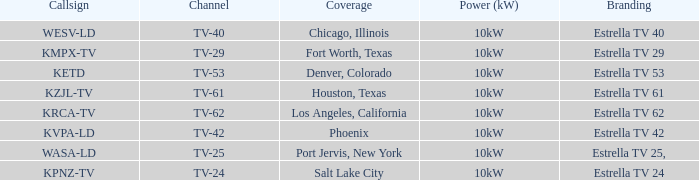Which city did kpnz-tv provide coverage for? Salt Lake City. 